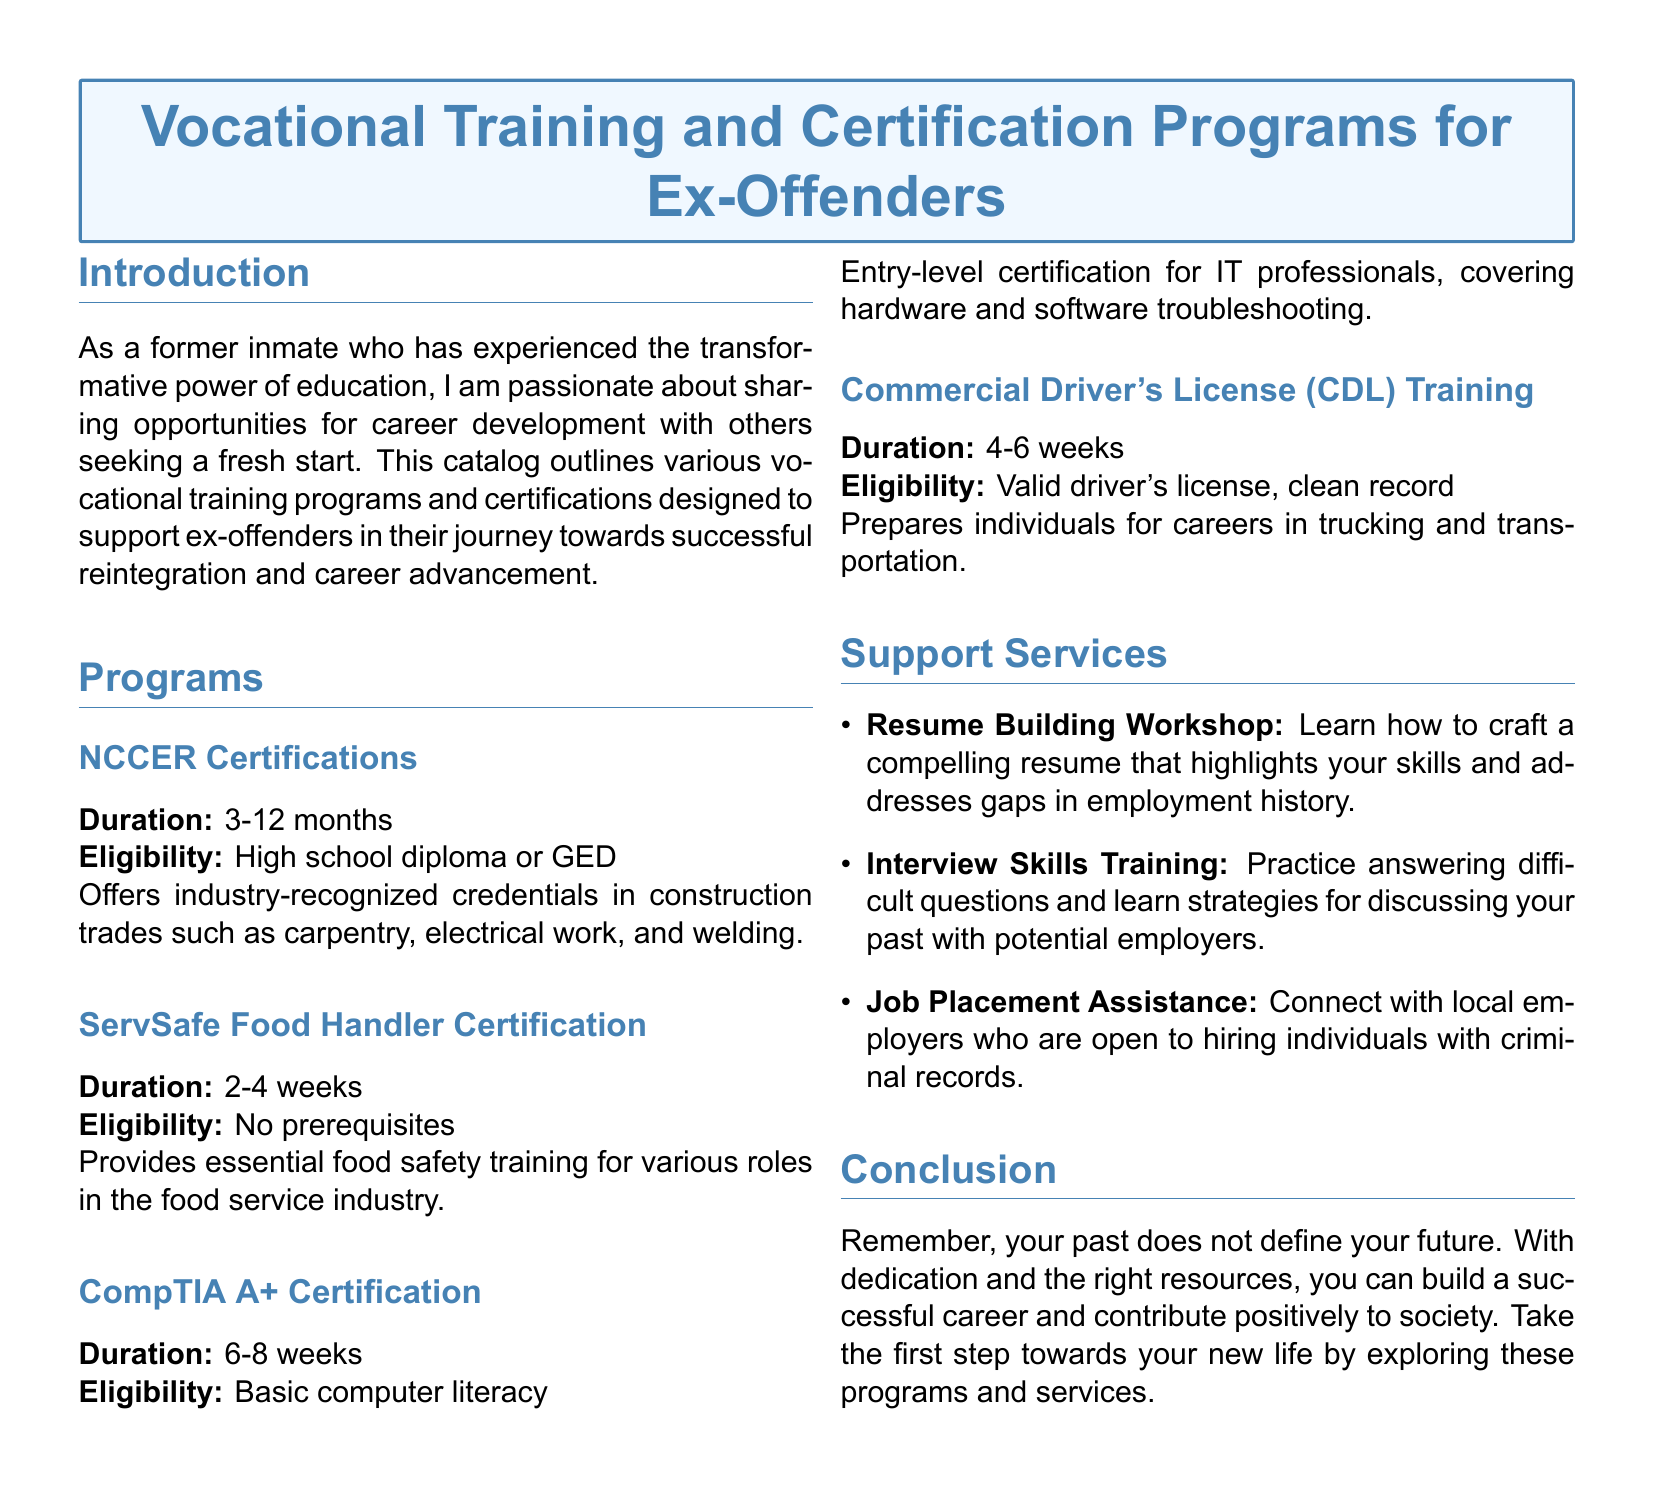What is the duration of NCCER Certifications? The duration of NCCER Certifications is mentioned in the document as 3-12 months.
Answer: 3-12 months What is the prerequisite for ServSafe Food Handler Certification? The document states there are no prerequisites for the ServSafe Food Handler Certification.
Answer: No prerequisites What is the focus of the CompTIA A+ Certification? The CompTIA A+ Certification covers hardware and software troubleshooting as stated in the document.
Answer: Hardware and software troubleshooting What type of support service helps with crafting resumes? The document specifies that the Resume Building Workshop helps with crafting resumes.
Answer: Resume Building Workshop What eligibility is required for CDL Training? The eligibility for CDL Training, as per the document, is a valid driver's license and a clean record.
Answer: Valid driver's license, clean record What is the primary goal of the training programs listed? The training programs aim to support career transitions for ex-offenders looking for a fresh start.
Answer: Support career transitions for ex-offenders How many weeks does the ServSafe Food Handler Certification take? The document states that the ServSafe Food Handler Certification takes 2-4 weeks.
Answer: 2-4 weeks What assistance is available regarding job placement? Job Placement Assistance is mentioned as a support service connecting ex-offenders with local employers.
Answer: Job Placement Assistance 